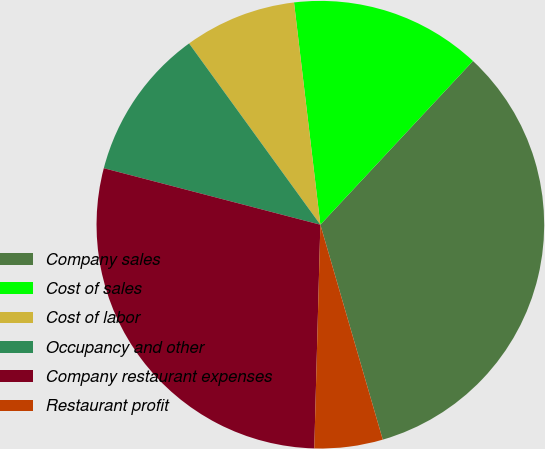Convert chart. <chart><loc_0><loc_0><loc_500><loc_500><pie_chart><fcel>Company sales<fcel>Cost of sales<fcel>Cost of labor<fcel>Occupancy and other<fcel>Company restaurant expenses<fcel>Restaurant profit<nl><fcel>33.56%<fcel>13.82%<fcel>8.1%<fcel>10.96%<fcel>28.63%<fcel>4.93%<nl></chart> 